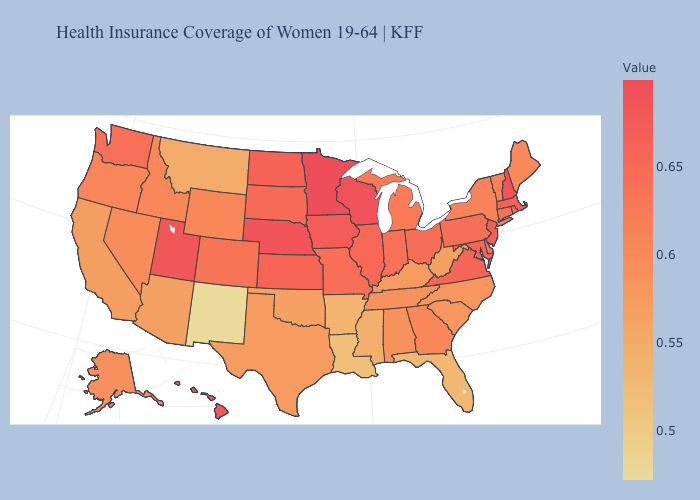Among the states that border Washington , which have the lowest value?
Keep it brief. Idaho. Does the map have missing data?
Write a very short answer. No. Which states have the lowest value in the USA?
Quick response, please. New Mexico. Does Minnesota have the highest value in the USA?
Write a very short answer. Yes. Among the states that border Montana , which have the lowest value?
Give a very brief answer. Idaho. 